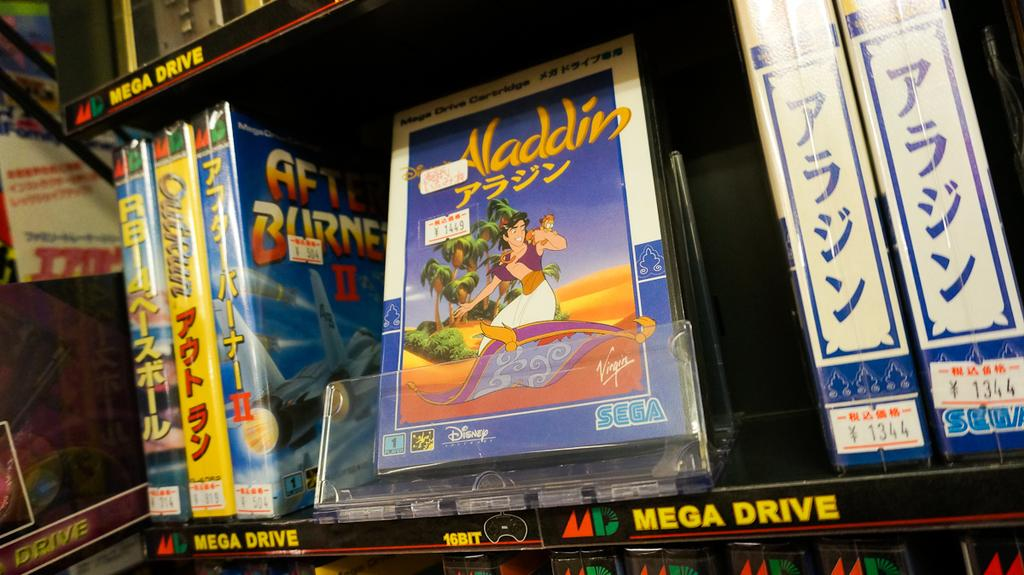What can be seen in the image related to reading materials? There are books in a rack in the image. What can be observed on the covers of the books? There are images on the books. What else can be found on the books besides the images? There is text on the books. What type of wine is being served in the image? There is no wine present in the image; it features books in a rack with images and text on their covers. 